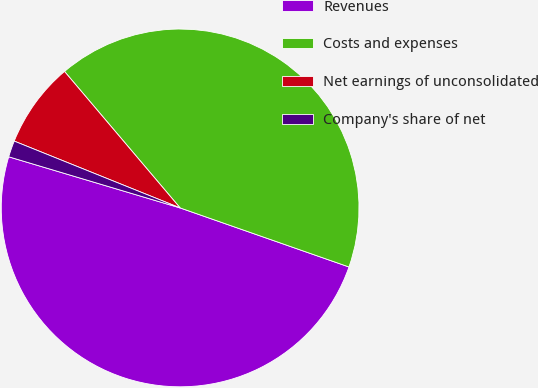<chart> <loc_0><loc_0><loc_500><loc_500><pie_chart><fcel>Revenues<fcel>Costs and expenses<fcel>Net earnings of unconsolidated<fcel>Company's share of net<nl><fcel>49.26%<fcel>41.54%<fcel>7.72%<fcel>1.48%<nl></chart> 